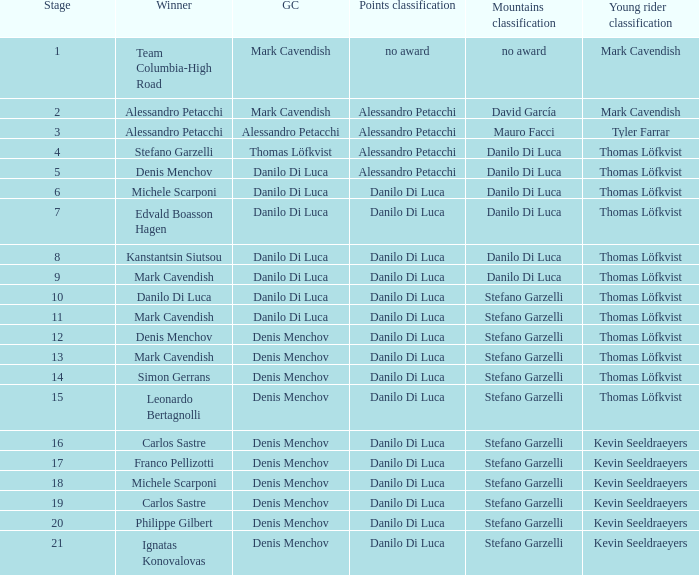When  thomas löfkvist is the general classification who is the winner? Stefano Garzelli. 